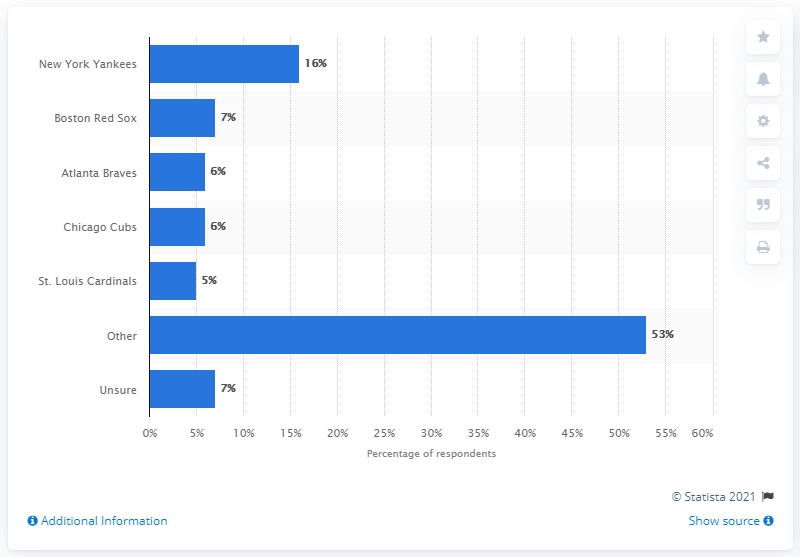Draw attention to some important aspects in this diagram. It is estimated that a significant percentage of Americans root for the New York Yankees. Specifically, it has been reported that approximately 16% of Americans are fans of the Yankees. 